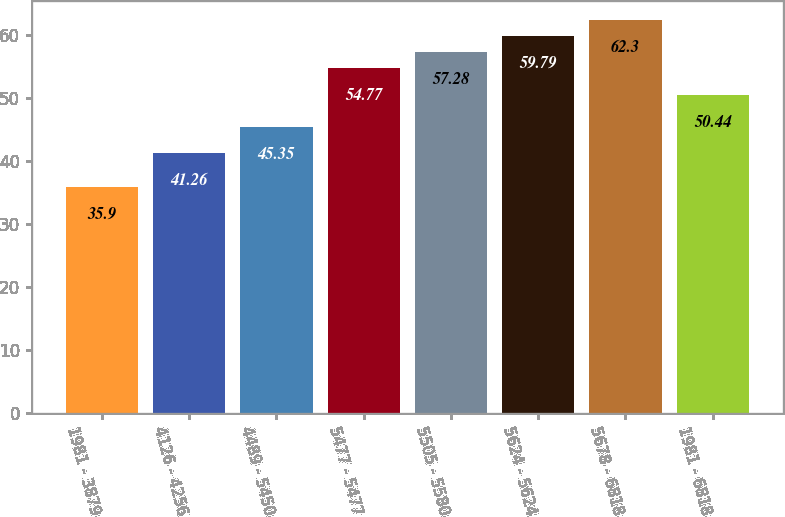Convert chart to OTSL. <chart><loc_0><loc_0><loc_500><loc_500><bar_chart><fcel>1981 - 3879<fcel>4126 - 4256<fcel>4489 - 5450<fcel>5477 - 5477<fcel>5505 - 5580<fcel>5624 - 5624<fcel>5678 - 6818<fcel>1981 - 6818<nl><fcel>35.9<fcel>41.26<fcel>45.35<fcel>54.77<fcel>57.28<fcel>59.79<fcel>62.3<fcel>50.44<nl></chart> 